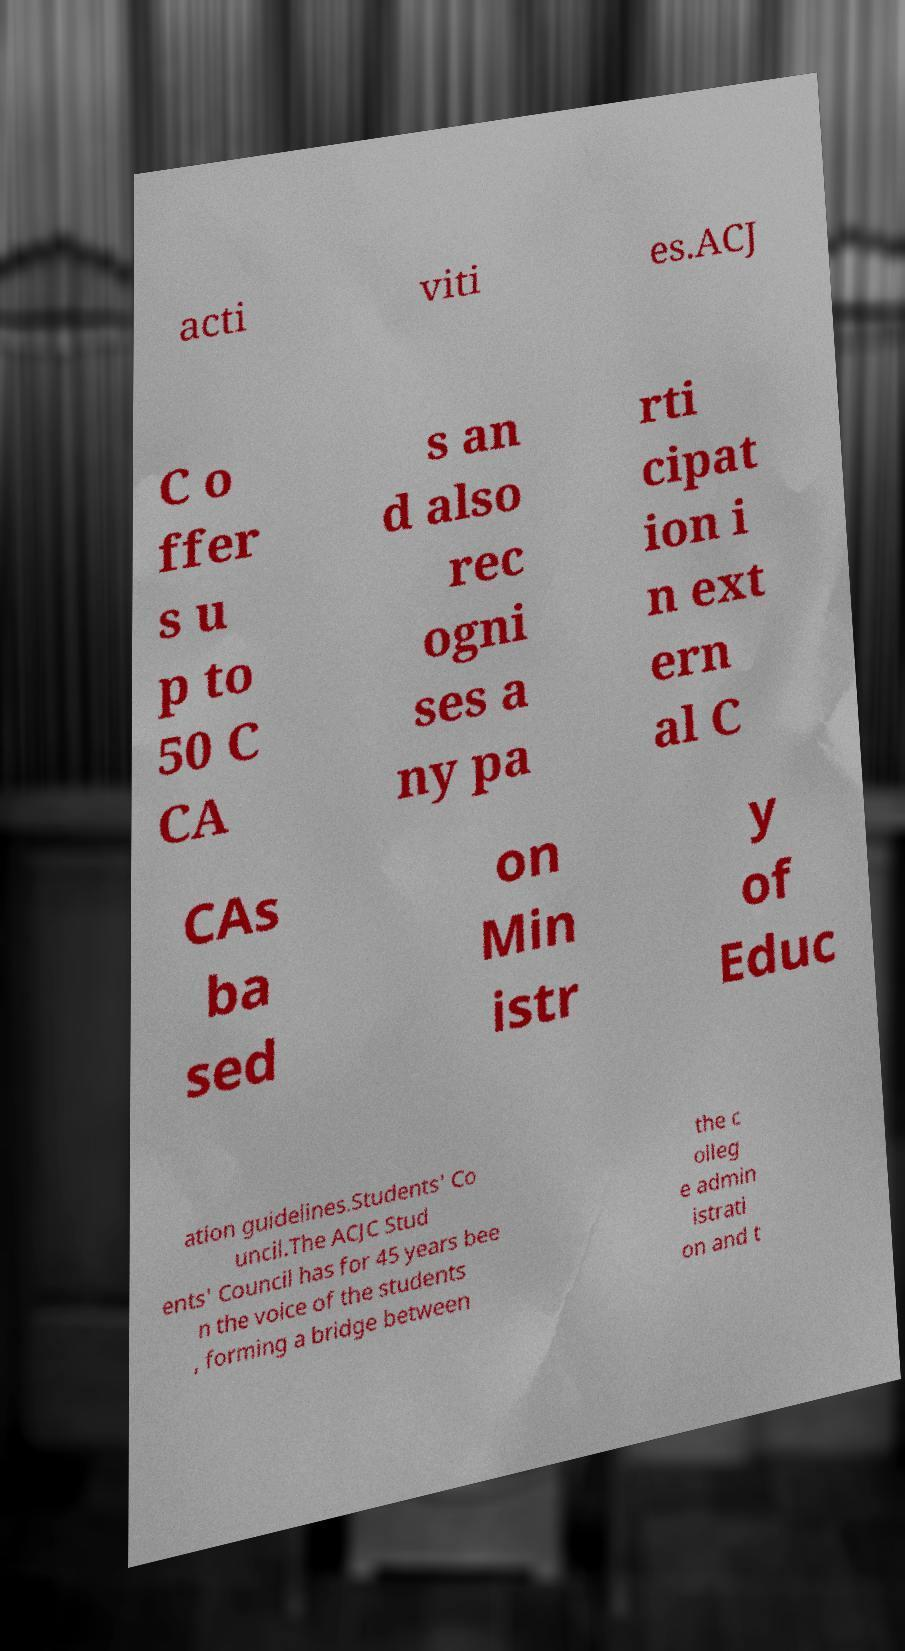Please read and relay the text visible in this image. What does it say? acti viti es.ACJ C o ffer s u p to 50 C CA s an d also rec ogni ses a ny pa rti cipat ion i n ext ern al C CAs ba sed on Min istr y of Educ ation guidelines.Students' Co uncil.The ACJC Stud ents' Council has for 45 years bee n the voice of the students , forming a bridge between the c olleg e admin istrati on and t 